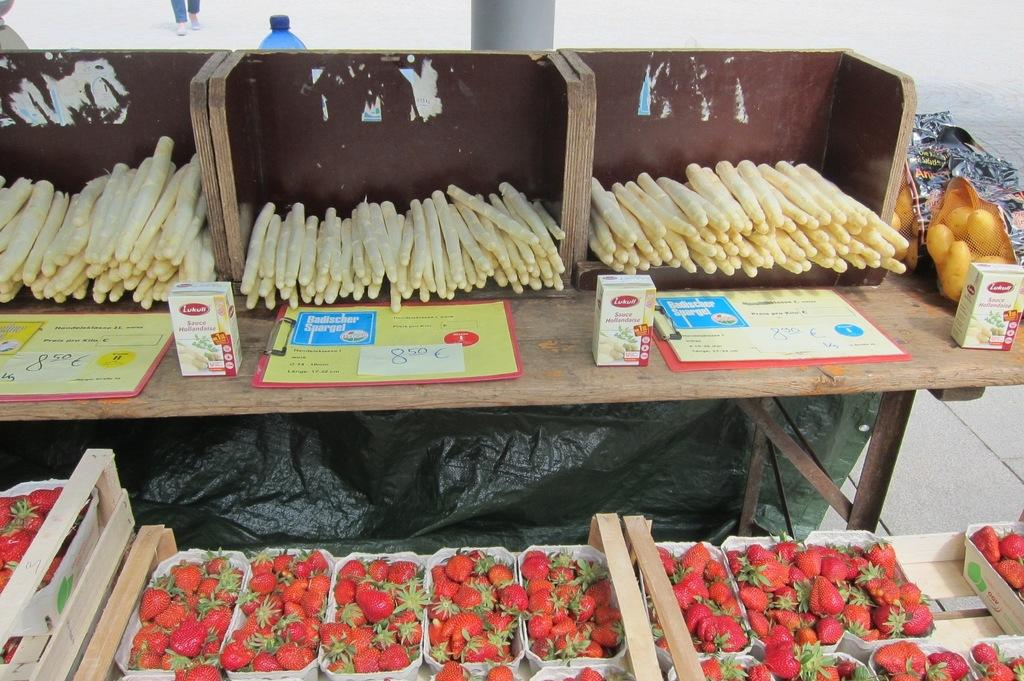What object can be seen in the image that might contain a liquid? There is a bottle in the image, which might contain a liquid. What type of surface is visible in the image? There is a table in the image. What type of food items can be seen on the table? There are vegetables, mangoes, and strawberries on the table. What other items can be seen on the table? There are posters and boxes on the table. What type of alarm is present on the table in the image? There is no alarm present on the table in the image. What type of shade is covering the table in the image? There is no shade covering the table in the image. 